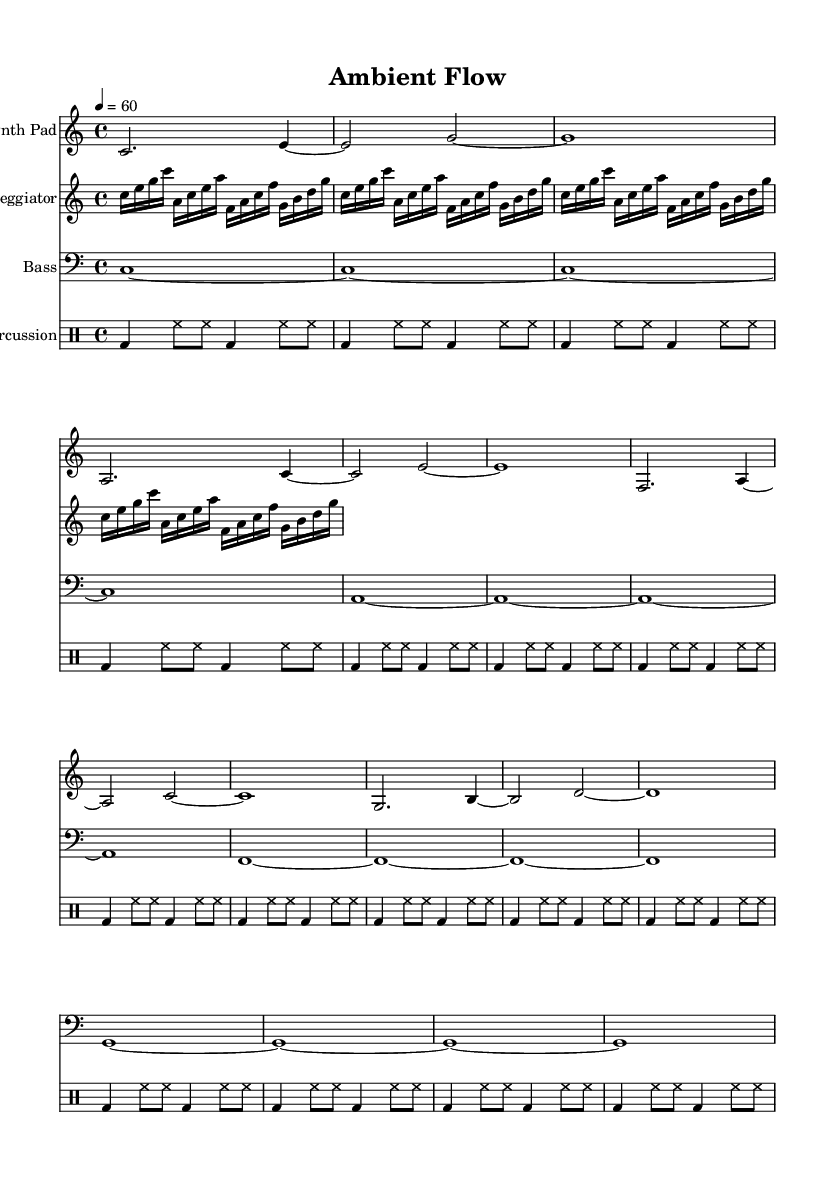What is the key signature of this music? The key signature is based on the global context defined at the beginning of the sheet music, which indicates C major. C major has no sharps or flats.
Answer: C major What is the time signature of this music? The time signature is found in the global context of the sheet music, specified as 4/4. This means there are four beats in a measure.
Answer: 4/4 What is the tempo marking for this piece? The tempo is stated in the global context under the tempo instruction, which indicates a speed of quarter note equals 60 beats per minute.
Answer: 60 What instruments are used in this composition? The instruments used are specified in the score section with their corresponding staff designations, which include Synth Pad, Arpeggiator, Bass, and Percussion.
Answer: Synth Pad, Arpeggiator, Bass, Percussion How many measures are in the synth pad part? To determine the number of measures, count the distinct bar lines in the Synth Pad staff. Each section separated by a bar line represents a measure, totaling 8 measures in this part.
Answer: 8 What rhythmic pattern is used in the percussion section? The percussion section features a repeated pattern of bass drum and hi-hat, indicated by the use of bd and hh notations in a structured loop over 16 beats. This creates a consistent and driving rhythm that is typical in electronic compositions.
Answer: bass drum and hi-hat pattern How does the bass line contribute to the overall ambiance of the piece? The bass line provides a sustained, continuous foundation, with each note held for a full measure. This creates a sense of stability and depth in the soundscape, facilitating focused work and productivity by allowing listeners to immerse in the ambient electronic texture without distractions.
Answer: Sustained foundation 